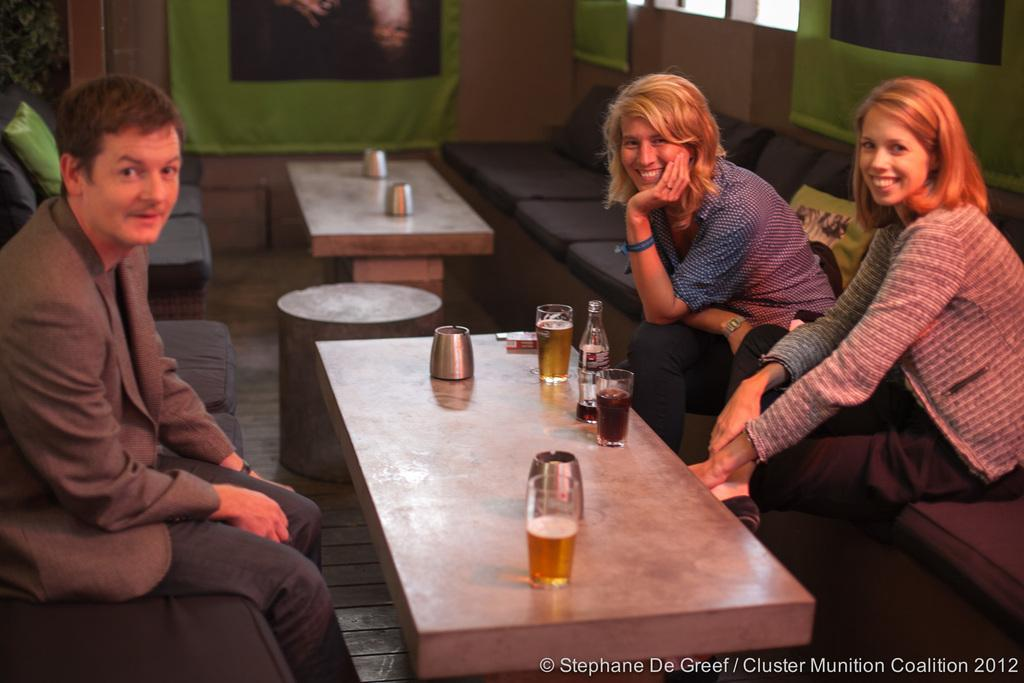How many people are in the image? There are two women and a man in the image. What are they doing in the image? They are sitting on a couch. What can be seen on the table in the background? There are glasses and a bottle on a table in the background. What is visible in the background of the image? There is a banner visible in the background. How many bikes are parked in the office in the image? There are no bikes or offices present in the image. 